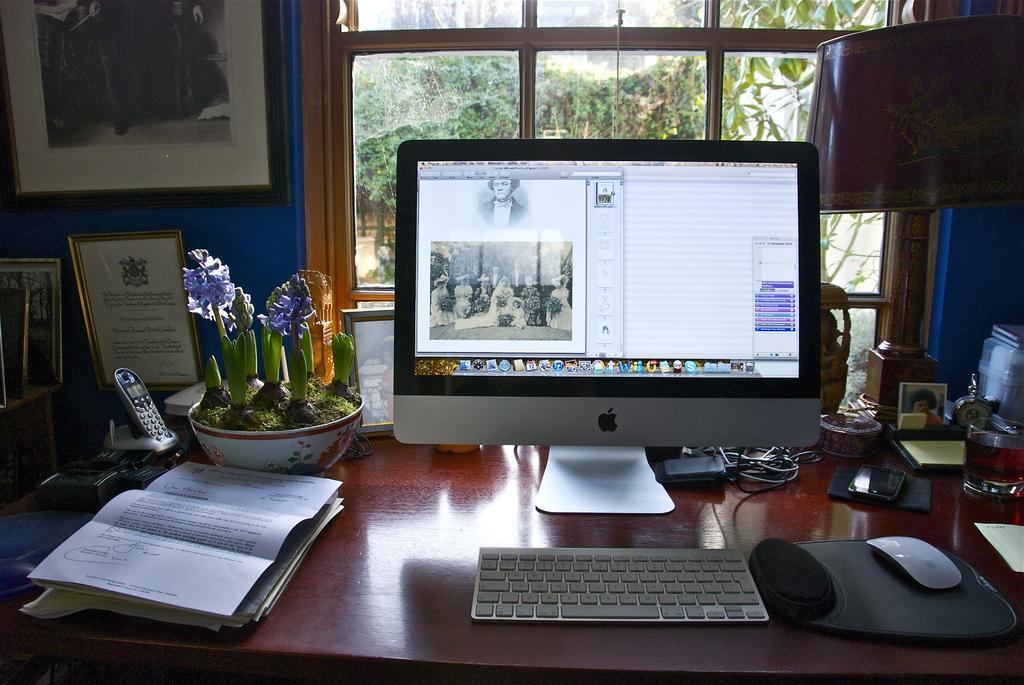How would you summarize this image in a sentence or two? In this picture there is a computer. There is a keyboard. There is a paper, a mobile phone and flower pot on the table. There is a mouse. There is a frame on the wall. There is also another frame. At the background there are some trees. There is a lamp and a glass to the right side. 